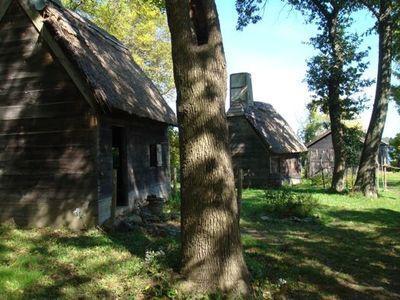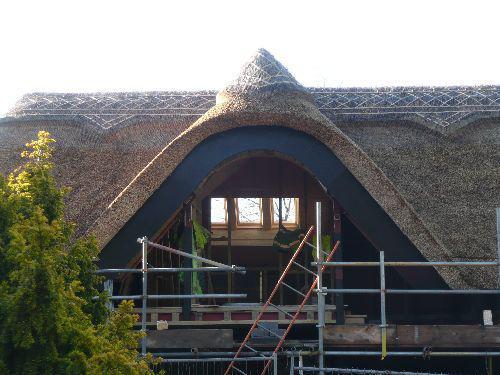The first image is the image on the left, the second image is the image on the right. For the images displayed, is the sentence "The left image features a house with multiple chimneys atop a dark gray roof with a scalloped border on top, and curving asymmetrical hedges in front." factually correct? Answer yes or no. No. The first image is the image on the left, the second image is the image on the right. Analyze the images presented: Is the assertion "In at least one image there are at least four oversized green bushes blocking the front of a home with at least two chimneys" valid? Answer yes or no. No. 